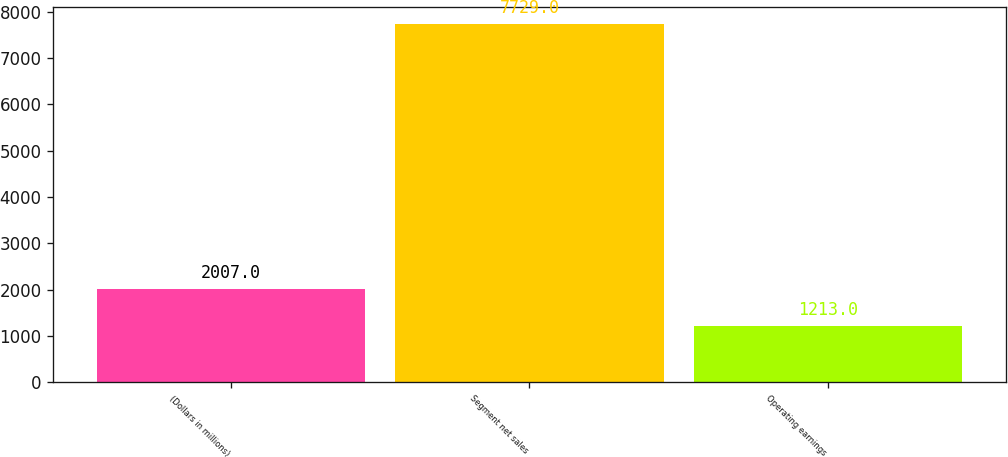Convert chart. <chart><loc_0><loc_0><loc_500><loc_500><bar_chart><fcel>(Dollars in millions)<fcel>Segment net sales<fcel>Operating earnings<nl><fcel>2007<fcel>7729<fcel>1213<nl></chart> 